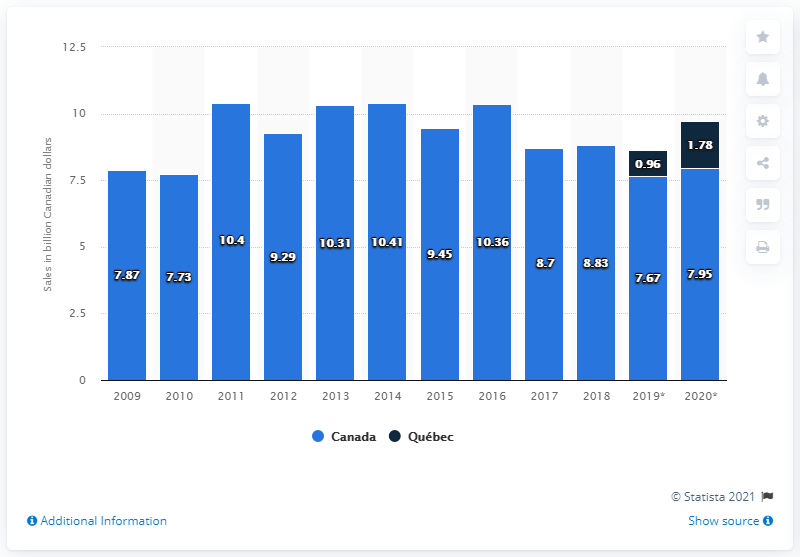Identify some key points in this picture. In 2020, the sales of provincial and territorial lotteries in Canada totaled 7.95 billion Canadian dollars. In 2016, Canada's highest lottery sales were 10.36. 